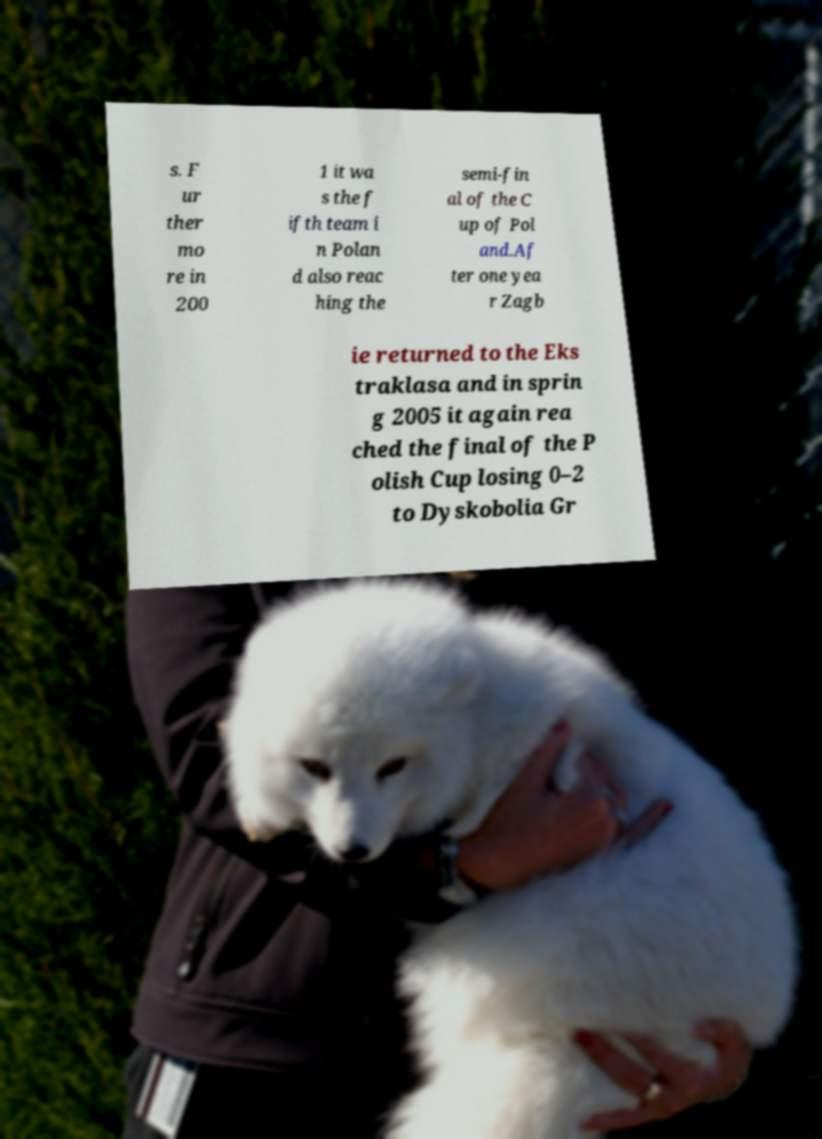What messages or text are displayed in this image? I need them in a readable, typed format. s. F ur ther mo re in 200 1 it wa s the f ifth team i n Polan d also reac hing the semi-fin al of the C up of Pol and.Af ter one yea r Zagb ie returned to the Eks traklasa and in sprin g 2005 it again rea ched the final of the P olish Cup losing 0–2 to Dyskobolia Gr 